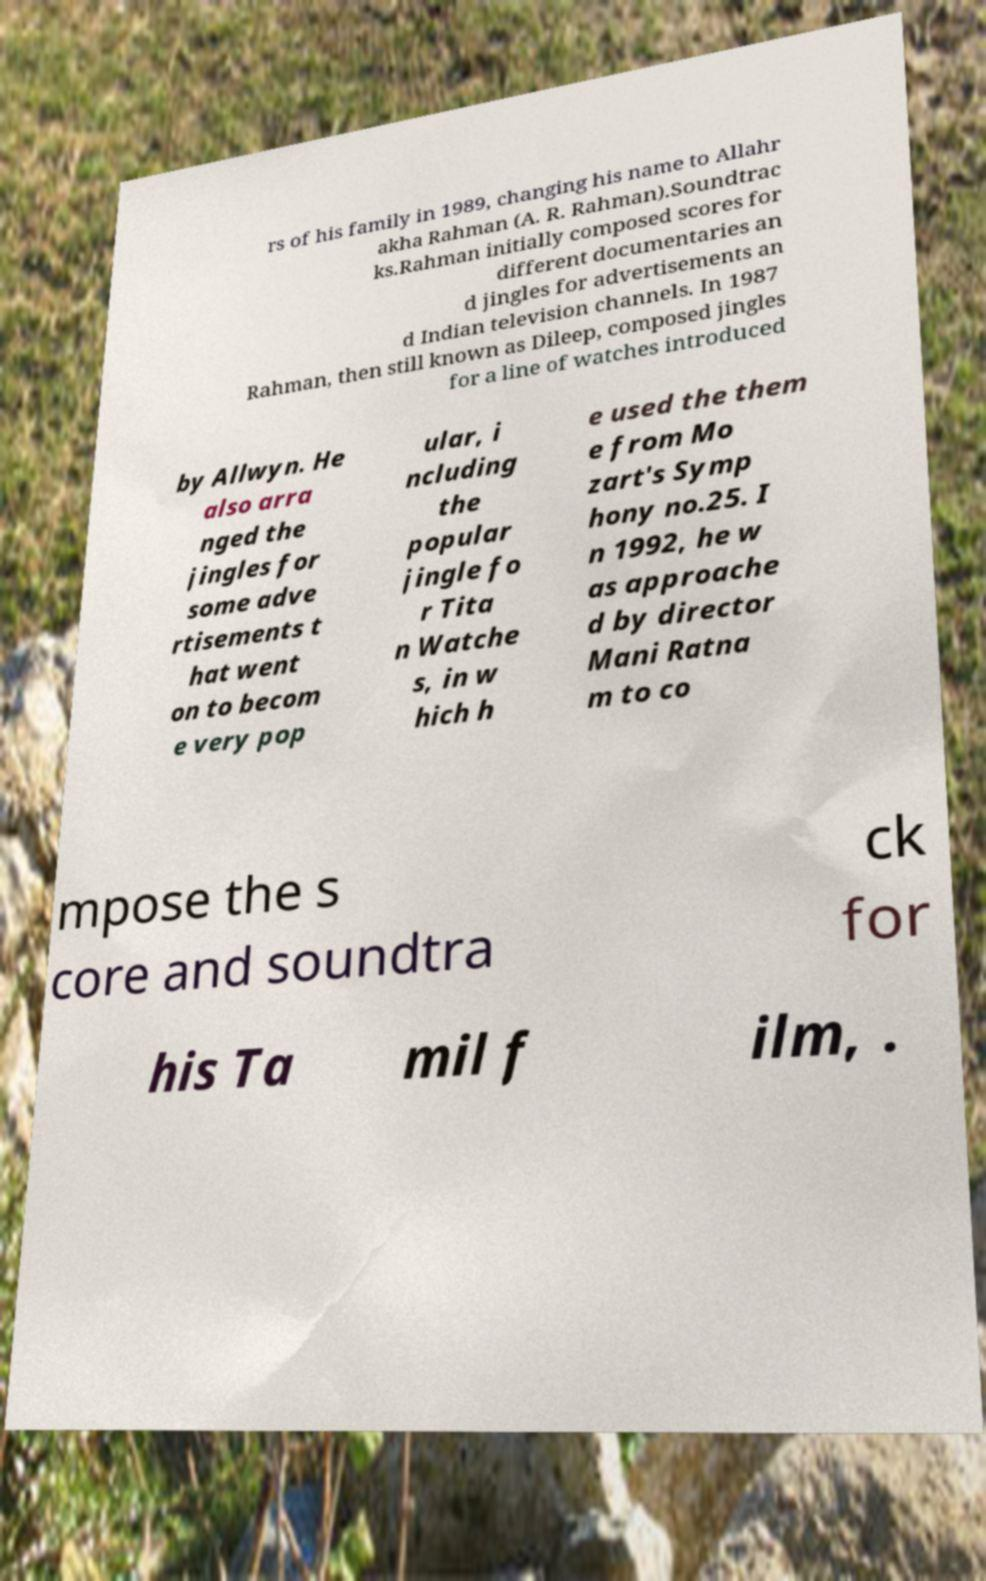Can you accurately transcribe the text from the provided image for me? rs of his family in 1989, changing his name to Allahr akha Rahman (A. R. Rahman).Soundtrac ks.Rahman initially composed scores for different documentaries an d jingles for advertisements an d Indian television channels. In 1987 Rahman, then still known as Dileep, composed jingles for a line of watches introduced by Allwyn. He also arra nged the jingles for some adve rtisements t hat went on to becom e very pop ular, i ncluding the popular jingle fo r Tita n Watche s, in w hich h e used the them e from Mo zart's Symp hony no.25. I n 1992, he w as approache d by director Mani Ratna m to co mpose the s core and soundtra ck for his Ta mil f ilm, . 